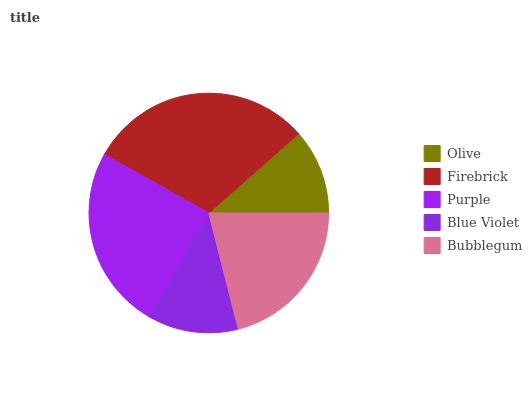Is Olive the minimum?
Answer yes or no. Yes. Is Firebrick the maximum?
Answer yes or no. Yes. Is Purple the minimum?
Answer yes or no. No. Is Purple the maximum?
Answer yes or no. No. Is Firebrick greater than Purple?
Answer yes or no. Yes. Is Purple less than Firebrick?
Answer yes or no. Yes. Is Purple greater than Firebrick?
Answer yes or no. No. Is Firebrick less than Purple?
Answer yes or no. No. Is Bubblegum the high median?
Answer yes or no. Yes. Is Bubblegum the low median?
Answer yes or no. Yes. Is Olive the high median?
Answer yes or no. No. Is Blue Violet the low median?
Answer yes or no. No. 